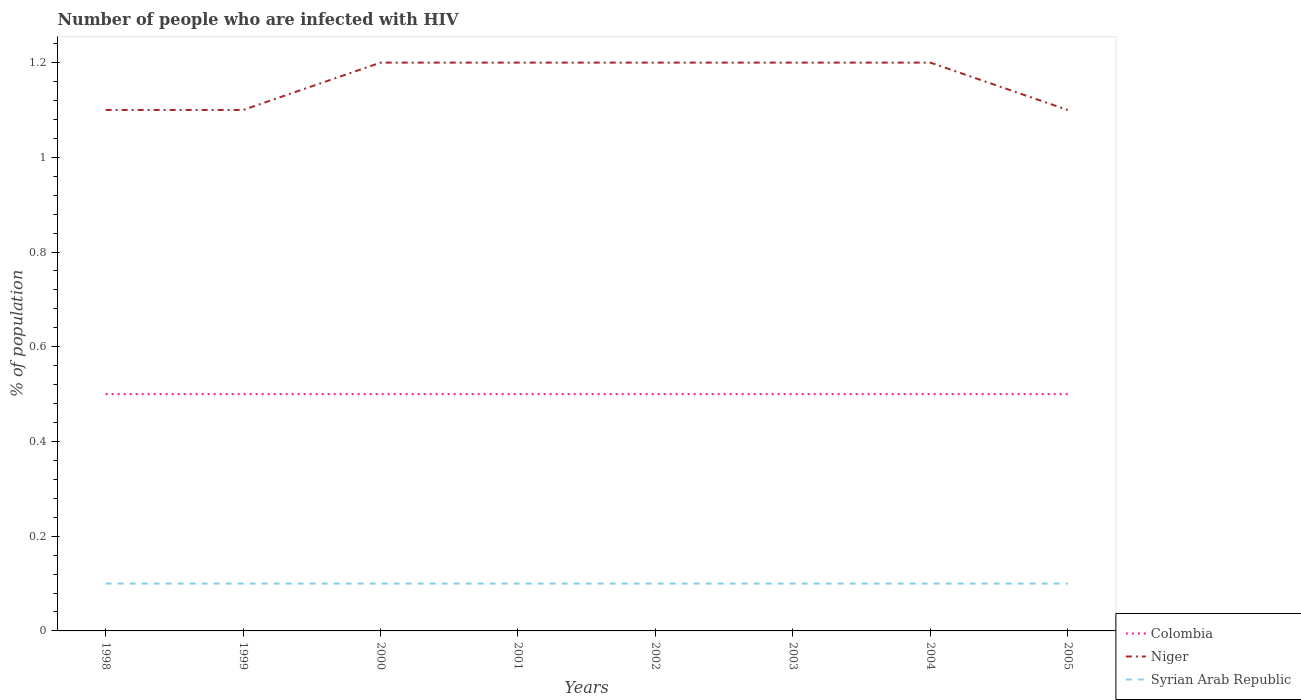How many different coloured lines are there?
Your answer should be very brief. 3. Is the number of lines equal to the number of legend labels?
Your answer should be compact. Yes. What is the difference between the highest and the second highest percentage of HIV infected population in in Syrian Arab Republic?
Your answer should be very brief. 0. What is the difference between the highest and the lowest percentage of HIV infected population in in Syrian Arab Republic?
Offer a terse response. 0. Is the percentage of HIV infected population in in Niger strictly greater than the percentage of HIV infected population in in Syrian Arab Republic over the years?
Your answer should be very brief. No. How many lines are there?
Make the answer very short. 3. Are the values on the major ticks of Y-axis written in scientific E-notation?
Offer a very short reply. No. Where does the legend appear in the graph?
Your response must be concise. Bottom right. How many legend labels are there?
Provide a succinct answer. 3. What is the title of the graph?
Your answer should be very brief. Number of people who are infected with HIV. Does "Least developed countries" appear as one of the legend labels in the graph?
Ensure brevity in your answer.  No. What is the label or title of the X-axis?
Your response must be concise. Years. What is the label or title of the Y-axis?
Your answer should be very brief. % of population. What is the % of population in Colombia in 2002?
Your response must be concise. 0.5. What is the % of population of Syrian Arab Republic in 2002?
Provide a short and direct response. 0.1. What is the % of population in Colombia in 2003?
Provide a succinct answer. 0.5. What is the % of population of Syrian Arab Republic in 2003?
Provide a succinct answer. 0.1. What is the % of population of Colombia in 2004?
Ensure brevity in your answer.  0.5. What is the % of population in Niger in 2004?
Offer a terse response. 1.2. What is the % of population of Syrian Arab Republic in 2004?
Your answer should be compact. 0.1. What is the % of population of Colombia in 2005?
Provide a succinct answer. 0.5. What is the % of population of Syrian Arab Republic in 2005?
Offer a terse response. 0.1. Across all years, what is the maximum % of population in Colombia?
Give a very brief answer. 0.5. Across all years, what is the maximum % of population in Niger?
Provide a short and direct response. 1.2. Across all years, what is the maximum % of population of Syrian Arab Republic?
Make the answer very short. 0.1. Across all years, what is the minimum % of population in Colombia?
Your response must be concise. 0.5. Across all years, what is the minimum % of population of Niger?
Your answer should be very brief. 1.1. What is the total % of population in Colombia in the graph?
Your answer should be very brief. 4. What is the difference between the % of population of Colombia in 1998 and that in 1999?
Keep it short and to the point. 0. What is the difference between the % of population in Colombia in 1998 and that in 2000?
Make the answer very short. 0. What is the difference between the % of population in Niger in 1998 and that in 2000?
Give a very brief answer. -0.1. What is the difference between the % of population of Syrian Arab Republic in 1998 and that in 2000?
Make the answer very short. 0. What is the difference between the % of population of Colombia in 1998 and that in 2002?
Ensure brevity in your answer.  0. What is the difference between the % of population of Niger in 1998 and that in 2002?
Provide a short and direct response. -0.1. What is the difference between the % of population of Syrian Arab Republic in 1998 and that in 2002?
Provide a succinct answer. 0. What is the difference between the % of population in Colombia in 1998 and that in 2003?
Offer a very short reply. 0. What is the difference between the % of population in Syrian Arab Republic in 1998 and that in 2003?
Offer a very short reply. 0. What is the difference between the % of population of Colombia in 1998 and that in 2004?
Make the answer very short. 0. What is the difference between the % of population of Syrian Arab Republic in 1998 and that in 2004?
Ensure brevity in your answer.  0. What is the difference between the % of population of Niger in 1998 and that in 2005?
Your answer should be compact. 0. What is the difference between the % of population in Niger in 1999 and that in 2000?
Make the answer very short. -0.1. What is the difference between the % of population in Niger in 1999 and that in 2001?
Provide a succinct answer. -0.1. What is the difference between the % of population of Syrian Arab Republic in 1999 and that in 2001?
Provide a short and direct response. 0. What is the difference between the % of population of Niger in 1999 and that in 2003?
Your answer should be compact. -0.1. What is the difference between the % of population of Niger in 1999 and that in 2004?
Provide a short and direct response. -0.1. What is the difference between the % of population of Syrian Arab Republic in 1999 and that in 2004?
Your response must be concise. 0. What is the difference between the % of population in Colombia in 1999 and that in 2005?
Your answer should be very brief. 0. What is the difference between the % of population in Niger in 1999 and that in 2005?
Offer a terse response. 0. What is the difference between the % of population of Niger in 2000 and that in 2001?
Give a very brief answer. 0. What is the difference between the % of population of Syrian Arab Republic in 2000 and that in 2001?
Offer a very short reply. 0. What is the difference between the % of population of Syrian Arab Republic in 2000 and that in 2003?
Ensure brevity in your answer.  0. What is the difference between the % of population of Niger in 2000 and that in 2004?
Give a very brief answer. 0. What is the difference between the % of population of Syrian Arab Republic in 2000 and that in 2004?
Your answer should be compact. 0. What is the difference between the % of population of Niger in 2000 and that in 2005?
Make the answer very short. 0.1. What is the difference between the % of population in Syrian Arab Republic in 2000 and that in 2005?
Keep it short and to the point. 0. What is the difference between the % of population in Colombia in 2001 and that in 2002?
Ensure brevity in your answer.  0. What is the difference between the % of population of Syrian Arab Republic in 2001 and that in 2002?
Ensure brevity in your answer.  0. What is the difference between the % of population in Colombia in 2001 and that in 2003?
Make the answer very short. 0. What is the difference between the % of population of Niger in 2001 and that in 2003?
Your answer should be compact. 0. What is the difference between the % of population in Niger in 2001 and that in 2004?
Ensure brevity in your answer.  0. What is the difference between the % of population in Niger in 2001 and that in 2005?
Ensure brevity in your answer.  0.1. What is the difference between the % of population of Colombia in 2002 and that in 2004?
Provide a short and direct response. 0. What is the difference between the % of population of Colombia in 2002 and that in 2005?
Give a very brief answer. 0. What is the difference between the % of population of Niger in 2002 and that in 2005?
Provide a succinct answer. 0.1. What is the difference between the % of population in Colombia in 2003 and that in 2004?
Your answer should be compact. 0. What is the difference between the % of population of Niger in 2003 and that in 2005?
Provide a succinct answer. 0.1. What is the difference between the % of population in Niger in 2004 and that in 2005?
Ensure brevity in your answer.  0.1. What is the difference between the % of population in Syrian Arab Republic in 2004 and that in 2005?
Ensure brevity in your answer.  0. What is the difference between the % of population of Colombia in 1998 and the % of population of Niger in 1999?
Offer a very short reply. -0.6. What is the difference between the % of population in Niger in 1998 and the % of population in Syrian Arab Republic in 1999?
Make the answer very short. 1. What is the difference between the % of population of Colombia in 1998 and the % of population of Niger in 2000?
Your answer should be compact. -0.7. What is the difference between the % of population of Colombia in 1998 and the % of population of Syrian Arab Republic in 2000?
Provide a short and direct response. 0.4. What is the difference between the % of population in Niger in 1998 and the % of population in Syrian Arab Republic in 2000?
Your response must be concise. 1. What is the difference between the % of population of Colombia in 1998 and the % of population of Niger in 2002?
Your response must be concise. -0.7. What is the difference between the % of population in Colombia in 1998 and the % of population in Syrian Arab Republic in 2002?
Offer a terse response. 0.4. What is the difference between the % of population in Niger in 1998 and the % of population in Syrian Arab Republic in 2002?
Make the answer very short. 1. What is the difference between the % of population in Colombia in 1998 and the % of population in Niger in 2003?
Ensure brevity in your answer.  -0.7. What is the difference between the % of population of Colombia in 1998 and the % of population of Syrian Arab Republic in 2003?
Keep it short and to the point. 0.4. What is the difference between the % of population in Niger in 1998 and the % of population in Syrian Arab Republic in 2003?
Make the answer very short. 1. What is the difference between the % of population of Colombia in 1998 and the % of population of Syrian Arab Republic in 2004?
Provide a short and direct response. 0.4. What is the difference between the % of population in Niger in 1998 and the % of population in Syrian Arab Republic in 2004?
Provide a succinct answer. 1. What is the difference between the % of population in Colombia in 1998 and the % of population in Niger in 2005?
Offer a terse response. -0.6. What is the difference between the % of population of Colombia in 1998 and the % of population of Syrian Arab Republic in 2005?
Your answer should be very brief. 0.4. What is the difference between the % of population in Niger in 1998 and the % of population in Syrian Arab Republic in 2005?
Your answer should be very brief. 1. What is the difference between the % of population in Colombia in 1999 and the % of population in Niger in 2000?
Your answer should be compact. -0.7. What is the difference between the % of population in Colombia in 1999 and the % of population in Syrian Arab Republic in 2000?
Your response must be concise. 0.4. What is the difference between the % of population in Niger in 1999 and the % of population in Syrian Arab Republic in 2000?
Offer a very short reply. 1. What is the difference between the % of population of Colombia in 1999 and the % of population of Niger in 2001?
Offer a terse response. -0.7. What is the difference between the % of population in Colombia in 1999 and the % of population in Syrian Arab Republic in 2001?
Give a very brief answer. 0.4. What is the difference between the % of population in Colombia in 1999 and the % of population in Syrian Arab Republic in 2002?
Offer a terse response. 0.4. What is the difference between the % of population in Colombia in 1999 and the % of population in Niger in 2003?
Provide a short and direct response. -0.7. What is the difference between the % of population of Colombia in 1999 and the % of population of Syrian Arab Republic in 2003?
Give a very brief answer. 0.4. What is the difference between the % of population of Niger in 1999 and the % of population of Syrian Arab Republic in 2003?
Offer a terse response. 1. What is the difference between the % of population of Colombia in 1999 and the % of population of Syrian Arab Republic in 2004?
Offer a very short reply. 0.4. What is the difference between the % of population in Niger in 1999 and the % of population in Syrian Arab Republic in 2004?
Offer a very short reply. 1. What is the difference between the % of population in Colombia in 1999 and the % of population in Niger in 2005?
Offer a very short reply. -0.6. What is the difference between the % of population in Colombia in 1999 and the % of population in Syrian Arab Republic in 2005?
Your answer should be compact. 0.4. What is the difference between the % of population of Niger in 1999 and the % of population of Syrian Arab Republic in 2005?
Your answer should be compact. 1. What is the difference between the % of population of Colombia in 2000 and the % of population of Niger in 2001?
Provide a succinct answer. -0.7. What is the difference between the % of population of Colombia in 2000 and the % of population of Niger in 2002?
Your answer should be compact. -0.7. What is the difference between the % of population of Colombia in 2000 and the % of population of Syrian Arab Republic in 2002?
Keep it short and to the point. 0.4. What is the difference between the % of population of Niger in 2000 and the % of population of Syrian Arab Republic in 2002?
Offer a very short reply. 1.1. What is the difference between the % of population of Colombia in 2000 and the % of population of Niger in 2003?
Offer a terse response. -0.7. What is the difference between the % of population of Colombia in 2000 and the % of population of Syrian Arab Republic in 2003?
Make the answer very short. 0.4. What is the difference between the % of population in Niger in 2000 and the % of population in Syrian Arab Republic in 2003?
Give a very brief answer. 1.1. What is the difference between the % of population of Colombia in 2000 and the % of population of Niger in 2004?
Keep it short and to the point. -0.7. What is the difference between the % of population in Colombia in 2000 and the % of population in Syrian Arab Republic in 2005?
Give a very brief answer. 0.4. What is the difference between the % of population of Niger in 2001 and the % of population of Syrian Arab Republic in 2003?
Provide a short and direct response. 1.1. What is the difference between the % of population in Niger in 2001 and the % of population in Syrian Arab Republic in 2004?
Make the answer very short. 1.1. What is the difference between the % of population of Colombia in 2001 and the % of population of Niger in 2005?
Keep it short and to the point. -0.6. What is the difference between the % of population of Niger in 2002 and the % of population of Syrian Arab Republic in 2003?
Ensure brevity in your answer.  1.1. What is the difference between the % of population of Colombia in 2002 and the % of population of Syrian Arab Republic in 2004?
Offer a terse response. 0.4. What is the difference between the % of population in Colombia in 2002 and the % of population in Niger in 2005?
Make the answer very short. -0.6. What is the difference between the % of population of Colombia in 2002 and the % of population of Syrian Arab Republic in 2005?
Keep it short and to the point. 0.4. What is the difference between the % of population in Niger in 2002 and the % of population in Syrian Arab Republic in 2005?
Provide a succinct answer. 1.1. What is the difference between the % of population in Colombia in 2003 and the % of population in Niger in 2005?
Keep it short and to the point. -0.6. What is the difference between the % of population of Colombia in 2003 and the % of population of Syrian Arab Republic in 2005?
Provide a short and direct response. 0.4. What is the difference between the % of population of Niger in 2003 and the % of population of Syrian Arab Republic in 2005?
Provide a short and direct response. 1.1. What is the difference between the % of population in Colombia in 2004 and the % of population in Syrian Arab Republic in 2005?
Provide a succinct answer. 0.4. What is the difference between the % of population of Niger in 2004 and the % of population of Syrian Arab Republic in 2005?
Offer a very short reply. 1.1. What is the average % of population in Niger per year?
Your answer should be compact. 1.16. In the year 1998, what is the difference between the % of population in Colombia and % of population in Niger?
Make the answer very short. -0.6. In the year 1998, what is the difference between the % of population in Niger and % of population in Syrian Arab Republic?
Your answer should be very brief. 1. In the year 1999, what is the difference between the % of population in Colombia and % of population in Niger?
Offer a very short reply. -0.6. In the year 1999, what is the difference between the % of population in Niger and % of population in Syrian Arab Republic?
Provide a short and direct response. 1. In the year 2000, what is the difference between the % of population of Colombia and % of population of Syrian Arab Republic?
Your answer should be very brief. 0.4. In the year 2000, what is the difference between the % of population in Niger and % of population in Syrian Arab Republic?
Ensure brevity in your answer.  1.1. In the year 2001, what is the difference between the % of population in Colombia and % of population in Niger?
Provide a short and direct response. -0.7. In the year 2001, what is the difference between the % of population of Colombia and % of population of Syrian Arab Republic?
Keep it short and to the point. 0.4. In the year 2001, what is the difference between the % of population of Niger and % of population of Syrian Arab Republic?
Offer a very short reply. 1.1. In the year 2002, what is the difference between the % of population of Colombia and % of population of Niger?
Provide a short and direct response. -0.7. In the year 2003, what is the difference between the % of population of Colombia and % of population of Niger?
Provide a short and direct response. -0.7. In the year 2003, what is the difference between the % of population of Niger and % of population of Syrian Arab Republic?
Provide a succinct answer. 1.1. In the year 2004, what is the difference between the % of population of Niger and % of population of Syrian Arab Republic?
Provide a short and direct response. 1.1. In the year 2005, what is the difference between the % of population in Colombia and % of population in Niger?
Offer a very short reply. -0.6. In the year 2005, what is the difference between the % of population of Colombia and % of population of Syrian Arab Republic?
Provide a short and direct response. 0.4. In the year 2005, what is the difference between the % of population in Niger and % of population in Syrian Arab Republic?
Make the answer very short. 1. What is the ratio of the % of population in Syrian Arab Republic in 1998 to that in 1999?
Keep it short and to the point. 1. What is the ratio of the % of population of Colombia in 1998 to that in 2000?
Ensure brevity in your answer.  1. What is the ratio of the % of population of Niger in 1998 to that in 2000?
Offer a very short reply. 0.92. What is the ratio of the % of population of Syrian Arab Republic in 1998 to that in 2000?
Your response must be concise. 1. What is the ratio of the % of population in Colombia in 1998 to that in 2002?
Keep it short and to the point. 1. What is the ratio of the % of population in Colombia in 1998 to that in 2003?
Your answer should be very brief. 1. What is the ratio of the % of population of Niger in 1998 to that in 2003?
Make the answer very short. 0.92. What is the ratio of the % of population in Syrian Arab Republic in 1998 to that in 2003?
Provide a succinct answer. 1. What is the ratio of the % of population in Niger in 1998 to that in 2004?
Keep it short and to the point. 0.92. What is the ratio of the % of population in Colombia in 1999 to that in 2000?
Your answer should be very brief. 1. What is the ratio of the % of population in Colombia in 1999 to that in 2002?
Offer a terse response. 1. What is the ratio of the % of population of Niger in 1999 to that in 2002?
Keep it short and to the point. 0.92. What is the ratio of the % of population of Syrian Arab Republic in 1999 to that in 2002?
Your answer should be very brief. 1. What is the ratio of the % of population in Colombia in 1999 to that in 2003?
Ensure brevity in your answer.  1. What is the ratio of the % of population of Niger in 1999 to that in 2004?
Your response must be concise. 0.92. What is the ratio of the % of population in Syrian Arab Republic in 1999 to that in 2004?
Your response must be concise. 1. What is the ratio of the % of population in Syrian Arab Republic in 1999 to that in 2005?
Offer a very short reply. 1. What is the ratio of the % of population in Colombia in 2000 to that in 2001?
Ensure brevity in your answer.  1. What is the ratio of the % of population of Niger in 2000 to that in 2001?
Offer a very short reply. 1. What is the ratio of the % of population of Colombia in 2000 to that in 2002?
Offer a very short reply. 1. What is the ratio of the % of population of Niger in 2000 to that in 2002?
Provide a short and direct response. 1. What is the ratio of the % of population of Syrian Arab Republic in 2000 to that in 2002?
Make the answer very short. 1. What is the ratio of the % of population in Syrian Arab Republic in 2000 to that in 2003?
Ensure brevity in your answer.  1. What is the ratio of the % of population of Colombia in 2000 to that in 2004?
Provide a short and direct response. 1. What is the ratio of the % of population in Niger in 2000 to that in 2004?
Keep it short and to the point. 1. What is the ratio of the % of population in Colombia in 2000 to that in 2005?
Provide a succinct answer. 1. What is the ratio of the % of population in Niger in 2000 to that in 2005?
Offer a very short reply. 1.09. What is the ratio of the % of population in Niger in 2001 to that in 2002?
Offer a terse response. 1. What is the ratio of the % of population of Colombia in 2001 to that in 2003?
Provide a short and direct response. 1. What is the ratio of the % of population of Niger in 2001 to that in 2004?
Provide a succinct answer. 1. What is the ratio of the % of population in Syrian Arab Republic in 2001 to that in 2004?
Your response must be concise. 1. What is the ratio of the % of population of Niger in 2001 to that in 2005?
Give a very brief answer. 1.09. What is the ratio of the % of population in Syrian Arab Republic in 2001 to that in 2005?
Provide a succinct answer. 1. What is the ratio of the % of population of Niger in 2002 to that in 2003?
Offer a terse response. 1. What is the ratio of the % of population of Colombia in 2002 to that in 2004?
Ensure brevity in your answer.  1. What is the ratio of the % of population of Syrian Arab Republic in 2002 to that in 2004?
Offer a terse response. 1. What is the ratio of the % of population of Colombia in 2002 to that in 2005?
Offer a terse response. 1. What is the ratio of the % of population in Colombia in 2003 to that in 2004?
Make the answer very short. 1. What is the ratio of the % of population in Niger in 2003 to that in 2004?
Offer a terse response. 1. What is the ratio of the % of population in Syrian Arab Republic in 2003 to that in 2004?
Your answer should be compact. 1. What is the ratio of the % of population of Colombia in 2003 to that in 2005?
Ensure brevity in your answer.  1. What is the ratio of the % of population in Colombia in 2004 to that in 2005?
Keep it short and to the point. 1. What is the ratio of the % of population of Niger in 2004 to that in 2005?
Your answer should be very brief. 1.09. What is the difference between the highest and the lowest % of population in Colombia?
Offer a very short reply. 0. What is the difference between the highest and the lowest % of population in Syrian Arab Republic?
Offer a very short reply. 0. 